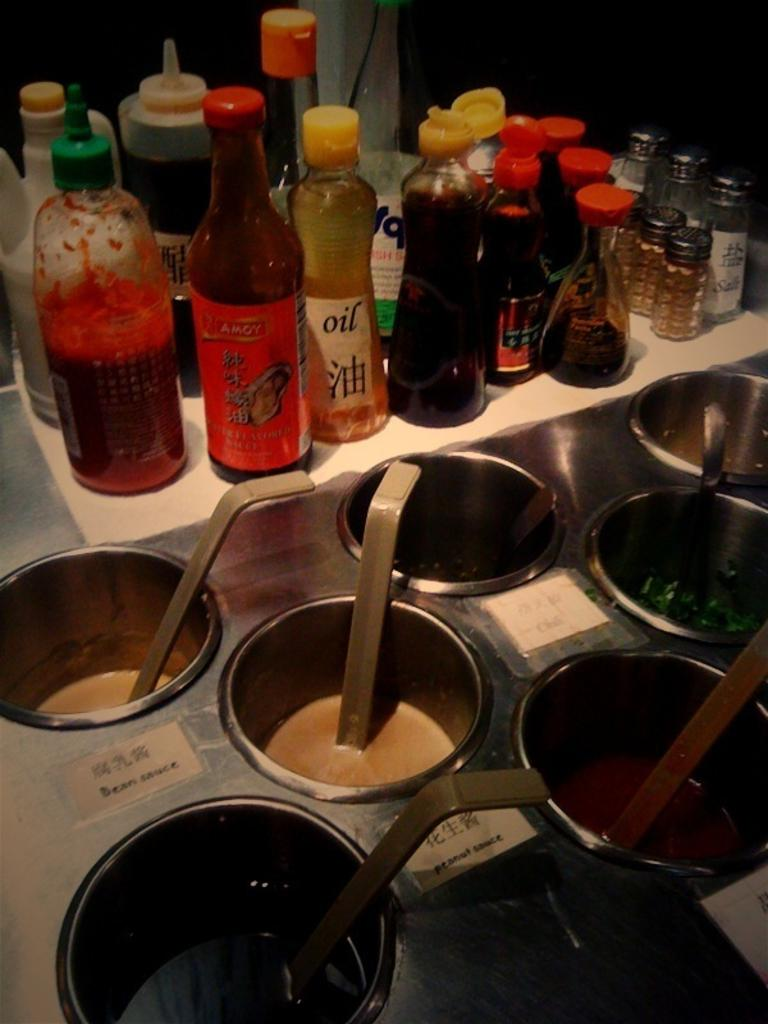What type of containers are present in the image? There are bottles in the image. What is inside the bottles? The bottles are full of liquid. What other type of containers can be seen in the image? There are bowls in the image. What is inside the bowls? The bowls are full of liquid. What type of butter is being crushed by the pet in the image? There is no butter or pet present in the image. 